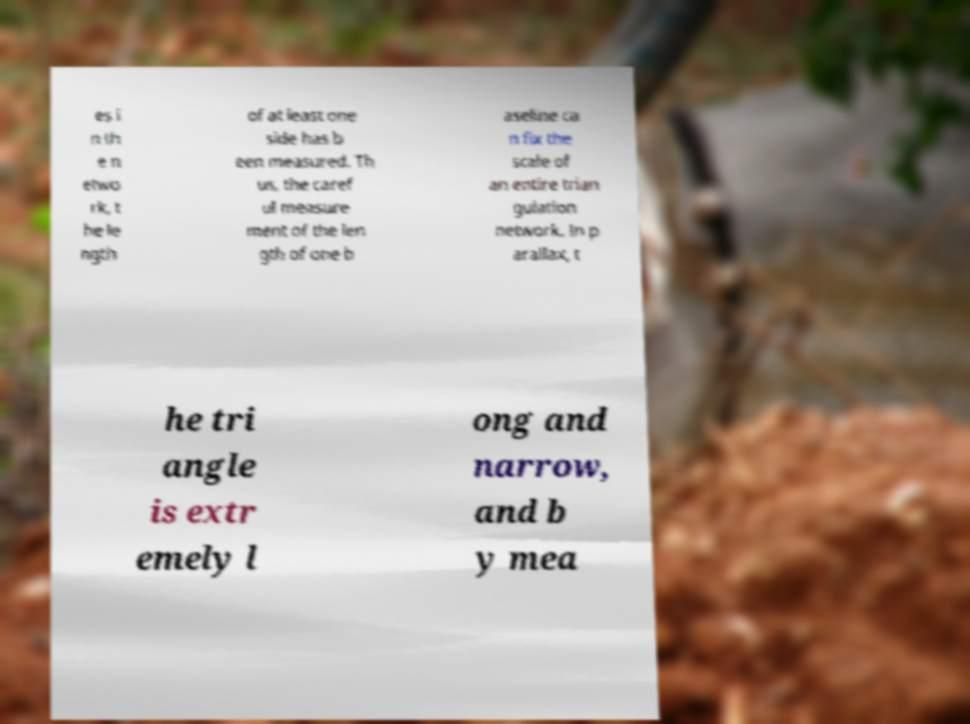What messages or text are displayed in this image? I need them in a readable, typed format. es i n th e n etwo rk, t he le ngth of at least one side has b een measured. Th us, the caref ul measure ment of the len gth of one b aseline ca n fix the scale of an entire trian gulation network. In p arallax, t he tri angle is extr emely l ong and narrow, and b y mea 